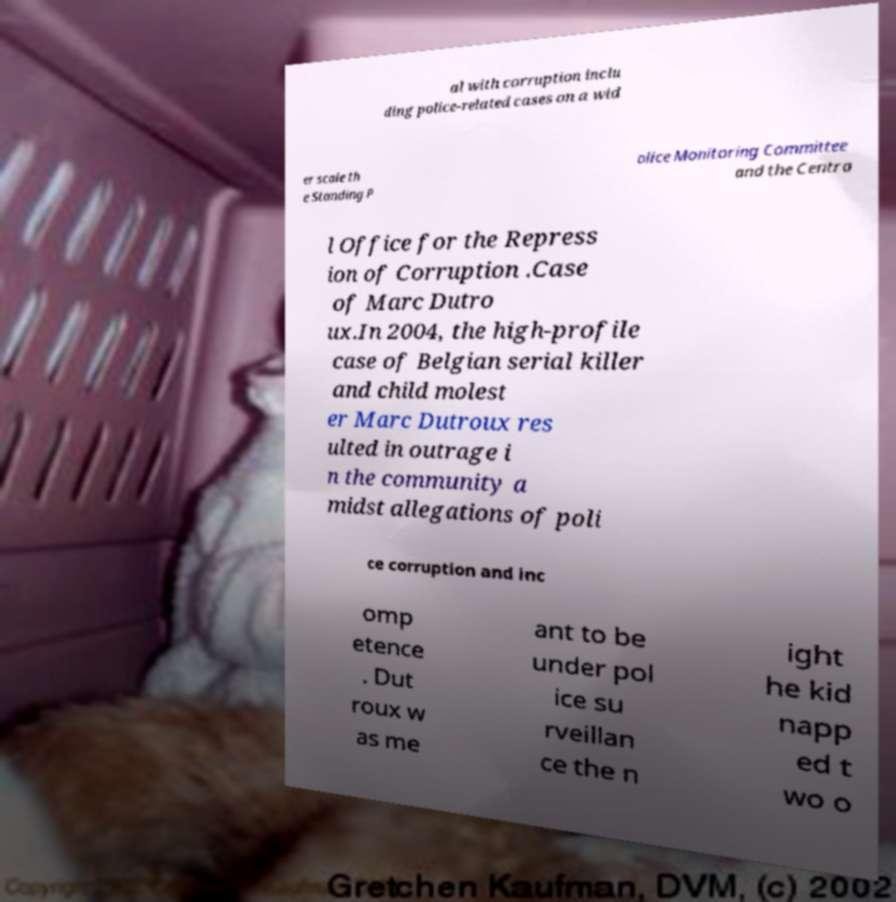Can you read and provide the text displayed in the image?This photo seems to have some interesting text. Can you extract and type it out for me? al with corruption inclu ding police-related cases on a wid er scale th e Standing P olice Monitoring Committee and the Centra l Office for the Repress ion of Corruption .Case of Marc Dutro ux.In 2004, the high-profile case of Belgian serial killer and child molest er Marc Dutroux res ulted in outrage i n the community a midst allegations of poli ce corruption and inc omp etence . Dut roux w as me ant to be under pol ice su rveillan ce the n ight he kid napp ed t wo o 